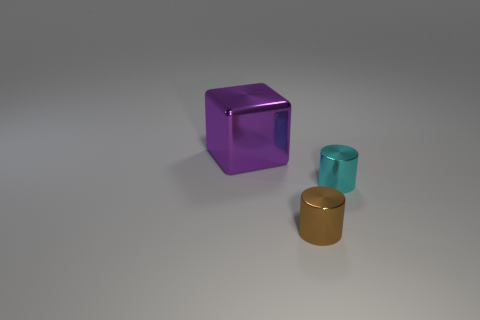Subtract all cubes. How many objects are left? 2 Subtract 2 cylinders. How many cylinders are left? 0 Add 2 purple shiny cubes. How many objects exist? 5 Subtract 0 gray balls. How many objects are left? 3 Subtract all cyan cylinders. Subtract all green cubes. How many cylinders are left? 1 Subtract all red spheres. How many cyan cylinders are left? 1 Subtract all brown metallic things. Subtract all cyan things. How many objects are left? 1 Add 1 shiny things. How many shiny things are left? 4 Add 2 large purple objects. How many large purple objects exist? 3 